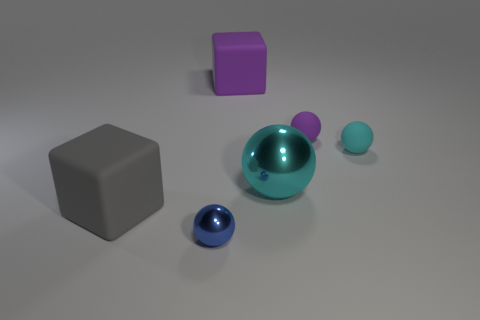What number of other objects are there of the same shape as the gray thing?
Ensure brevity in your answer.  1. There is a rubber cube right of the big rubber thing that is in front of the large cyan metallic thing; how big is it?
Offer a terse response. Large. Are any big green rubber cylinders visible?
Your answer should be compact. No. There is a metallic object that is behind the large gray matte object; how many small matte things are in front of it?
Your response must be concise. 0. What shape is the big object to the left of the tiny blue metallic thing?
Your response must be concise. Cube. What is the material of the big object on the right side of the rubber cube behind the big rubber cube that is in front of the tiny cyan rubber sphere?
Provide a short and direct response. Metal. What material is the small blue thing that is the same shape as the large cyan object?
Provide a short and direct response. Metal. The big shiny sphere has what color?
Your answer should be compact. Cyan. What is the color of the large rubber object that is in front of the matte block right of the blue ball?
Give a very brief answer. Gray. There is a big sphere; is its color the same as the matte ball in front of the tiny purple sphere?
Your answer should be compact. Yes. 